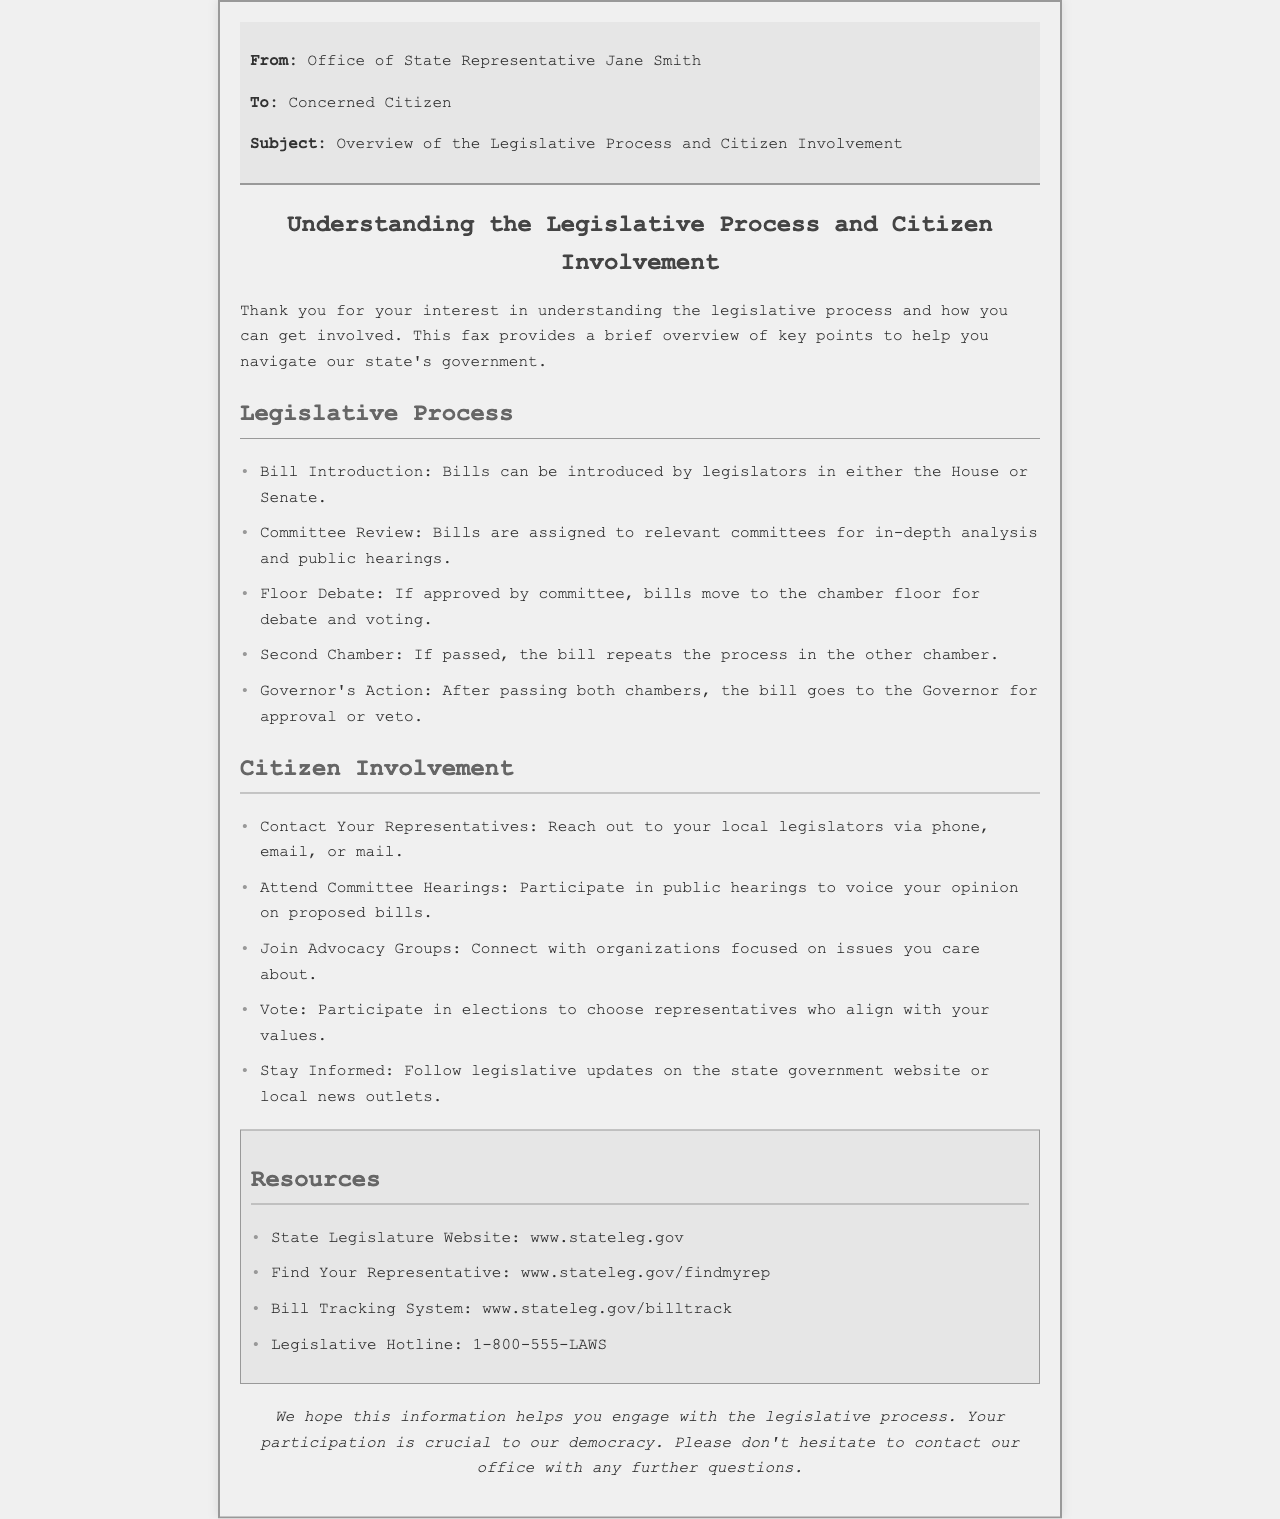What is the name of the state representative? The document indicates that the fax is from the office of State Representative Jane Smith.
Answer: Jane Smith How can citizens contact their representatives? The document states that citizens can reach out to their local legislators via phone, email, or mail.
Answer: Phone, email, or mail What is the first step in the legislative process? According to the document, the first step in the legislative process is bill introduction.
Answer: Bill Introduction What action does the governor take after a bill passes both chambers? The document mentions that the bill goes to the Governor for approval or veto after passing both chambers.
Answer: Approval or veto Which resource provides information on finding a representative? The document includes a resource titled "Find Your Representative" that can help citizens locate their legislators.
Answer: www.stateleg.gov/findmyrep What is one way citizens can participate in the legislative process? The document lists attending committee hearings as a way for citizens to engage in the legislative process.
Answer: Attend Committee Hearings What should citizens do to stay informed? Citizens are advised to follow legislative updates on the state government website or local news outlets to stay informed.
Answer: State government website or local news outlets What is a resource for tracking bills? The document provides a specific resource called the "Bill Tracking System" for tracking bills.
Answer: www.stateleg.gov/billtrack 